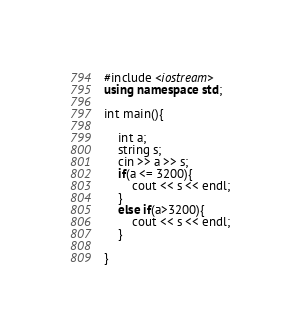<code> <loc_0><loc_0><loc_500><loc_500><_C++_>#include <iostream>
using namespace std;

int main(){

    int a;
    string s;
    cin >> a >> s;    
    if(a <= 3200){
        cout << s << endl;
    }
    else if(a>3200){
        cout << s << endl;
    }
    
}</code> 